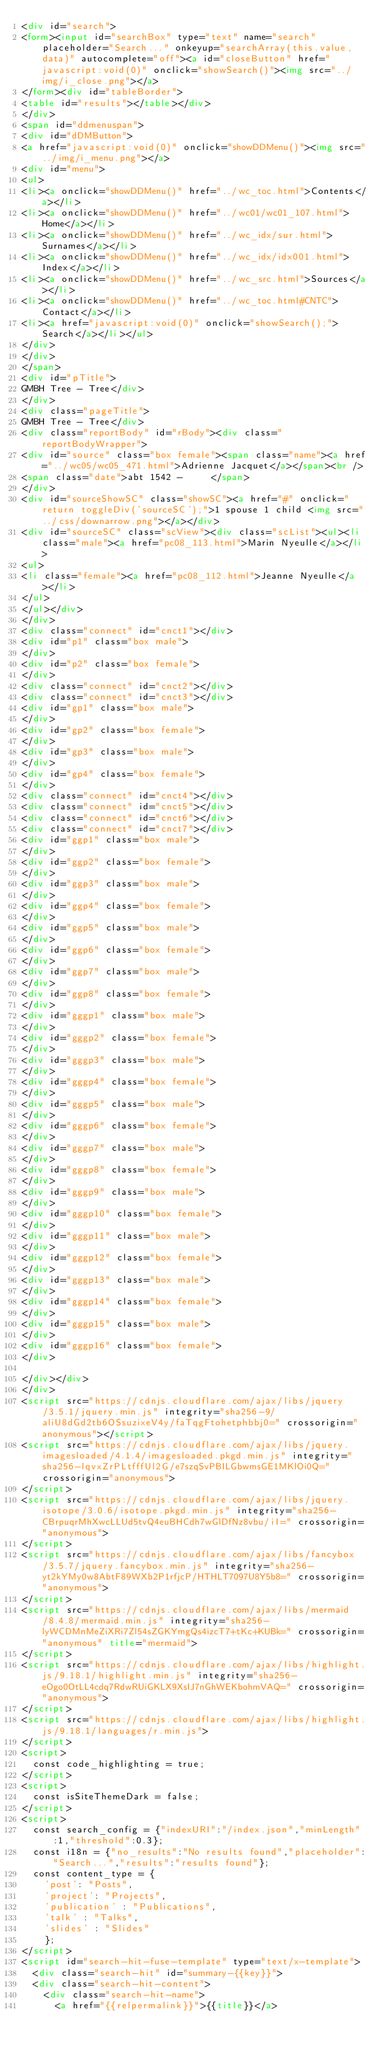<code> <loc_0><loc_0><loc_500><loc_500><_HTML_><div id="search">
<form><input id="searchBox" type="text" name="search" placeholder="Search..." onkeyup="searchArray(this.value,data)" autocomplete="off"><a id="closeButton" href="javascript:void(0)" onclick="showSearch()"><img src="../img/i_close.png"></a>
</form><div id="tableBorder">
<table id="results"></table></div>
</div>
<span id="ddmenuspan">
<div id="dDMButton">
<a href="javascript:void(0)" onclick="showDDMenu()"><img src="../img/i_menu.png"></a>
<div id="menu">
<ul>
<li><a onclick="showDDMenu()" href="../wc_toc.html">Contents</a></li>
<li><a onclick="showDDMenu()" href="../wc01/wc01_107.html">Home</a></li>
<li><a onclick="showDDMenu()" href="../wc_idx/sur.html">Surnames</a></li>
<li><a onclick="showDDMenu()" href="../wc_idx/idx001.html">Index</a></li>
<li><a onclick="showDDMenu()" href="../wc_src.html">Sources</a></li>
<li><a onclick="showDDMenu()" href="../wc_toc.html#CNTC">Contact</a></li>
<li><a href="javascript:void(0)" onclick="showSearch();">Search</a></li></ul>
</div>
</div>
</span>
<div id="pTitle">
GMBH Tree - Tree</div>
</div>
<div class="pageTitle">
GMBH Tree - Tree</div>
<div class="reportBody" id="rBody"><div class="reportBodyWrapper">
<div id="source" class="box female"><span class="name"><a href="../wc05/wc05_471.html">Adrienne Jacquet</a></span><br />
<span class="date">abt 1542 -     </span>
</div>
<div id="sourceShowSC" class="showSC"><a href="#" onclick="return toggleDiv('sourceSC');">1 spouse 1 child <img src="../css/downarrow.png"></a></div>
<div id="sourceSC" class="scView"><div class="scList"><ul><li class="male"><a href="pc08_113.html">Marin Nyeulle</a></li>
<ul>
<li class="female"><a href="pc08_112.html">Jeanne Nyeulle</a></li>
</ul>
</ul></div>
</div>
<div class="connect" id="cnct1"></div>
<div id="p1" class="box male">
</div>
<div id="p2" class="box female">
</div>
<div class="connect" id="cnct2"></div>
<div class="connect" id="cnct3"></div>
<div id="gp1" class="box male">
</div>
<div id="gp2" class="box female">
</div>
<div id="gp3" class="box male">
</div>
<div id="gp4" class="box female">
</div>
<div class="connect" id="cnct4"></div>
<div class="connect" id="cnct5"></div>
<div class="connect" id="cnct6"></div>
<div class="connect" id="cnct7"></div>
<div id="ggp1" class="box male">
</div>
<div id="ggp2" class="box female">
</div>
<div id="ggp3" class="box male">
</div>
<div id="ggp4" class="box female">
</div>
<div id="ggp5" class="box male">
</div>
<div id="ggp6" class="box female">
</div>
<div id="ggp7" class="box male">
</div>
<div id="ggp8" class="box female">
</div>
<div id="gggp1" class="box male">
</div>
<div id="gggp2" class="box female">
</div>
<div id="gggp3" class="box male">
</div>
<div id="gggp4" class="box female">
</div>
<div id="gggp5" class="box male">
</div>
<div id="gggp6" class="box female">
</div>
<div id="gggp7" class="box male">
</div>
<div id="gggp8" class="box female">
</div>
<div id="gggp9" class="box male">
</div>
<div id="gggp10" class="box female">
</div>
<div id="gggp11" class="box male">
</div>
<div id="gggp12" class="box female">
</div>
<div id="gggp13" class="box male">
</div>
<div id="gggp14" class="box female">
</div>
<div id="gggp15" class="box male">
</div>
<div id="gggp16" class="box female">
</div>

</div></div>
</div>
<script src="https://cdnjs.cloudflare.com/ajax/libs/jquery/3.5.1/jquery.min.js" integrity="sha256-9/aliU8dGd2tb6OSsuzixeV4y/faTqgFtohetphbbj0=" crossorigin="anonymous"></script>
<script src="https://cdnjs.cloudflare.com/ajax/libs/jquery.imagesloaded/4.1.4/imagesloaded.pkgd.min.js" integrity="sha256-lqvxZrPLtfffUl2G/e7szqSvPBILGbwmsGE1MKlOi0Q=" crossorigin="anonymous">
</script>
<script src="https://cdnjs.cloudflare.com/ajax/libs/jquery.isotope/3.0.6/isotope.pkgd.min.js" integrity="sha256-CBrpuqrMhXwcLLUd5tvQ4euBHCdh7wGlDfNz8vbu/iI=" crossorigin="anonymous">
</script>
<script src="https://cdnjs.cloudflare.com/ajax/libs/fancybox/3.5.7/jquery.fancybox.min.js" integrity="sha256-yt2kYMy0w8AbtF89WXb2P1rfjcP/HTHLT7097U8Y5b8=" crossorigin="anonymous">
</script>
<script src="https://cdnjs.cloudflare.com/ajax/libs/mermaid/8.4.8/mermaid.min.js" integrity="sha256-lyWCDMnMeZiXRi7Zl54sZGKYmgQs4izcT7+tKc+KUBk=" crossorigin="anonymous" title="mermaid">
</script>
<script src="https://cdnjs.cloudflare.com/ajax/libs/highlight.js/9.18.1/highlight.min.js" integrity="sha256-eOgo0OtLL4cdq7RdwRUiGKLX9XsIJ7nGhWEKbohmVAQ=" crossorigin="anonymous">
</script>
<script src="https://cdnjs.cloudflare.com/ajax/libs/highlight.js/9.18.1/languages/r.min.js">
</script>
<script>
	const code_highlighting = true;
</script>
<script>
	const isSiteThemeDark = false;
</script>
<script>
	const search_config = {"indexURI":"/index.json","minLength":1,"threshold":0.3};
	const i18n = {"no_results":"No results found","placeholder":"Search...","results":"results found"};
	const content_type = {
	  'post': "Posts",
	  'project': "Projects",
	  'publication' : "Publications",
	  'talk' : "Talks",
	  'slides' : "Slides"
	  };
</script>
<script id="search-hit-fuse-template" type="text/x-template">
	<div class="search-hit" id="summary-{{key}}">
	<div class="search-hit-content">
	  <div class="search-hit-name">
	    <a href="{{relpermalink}}">{{title}}</a></code> 